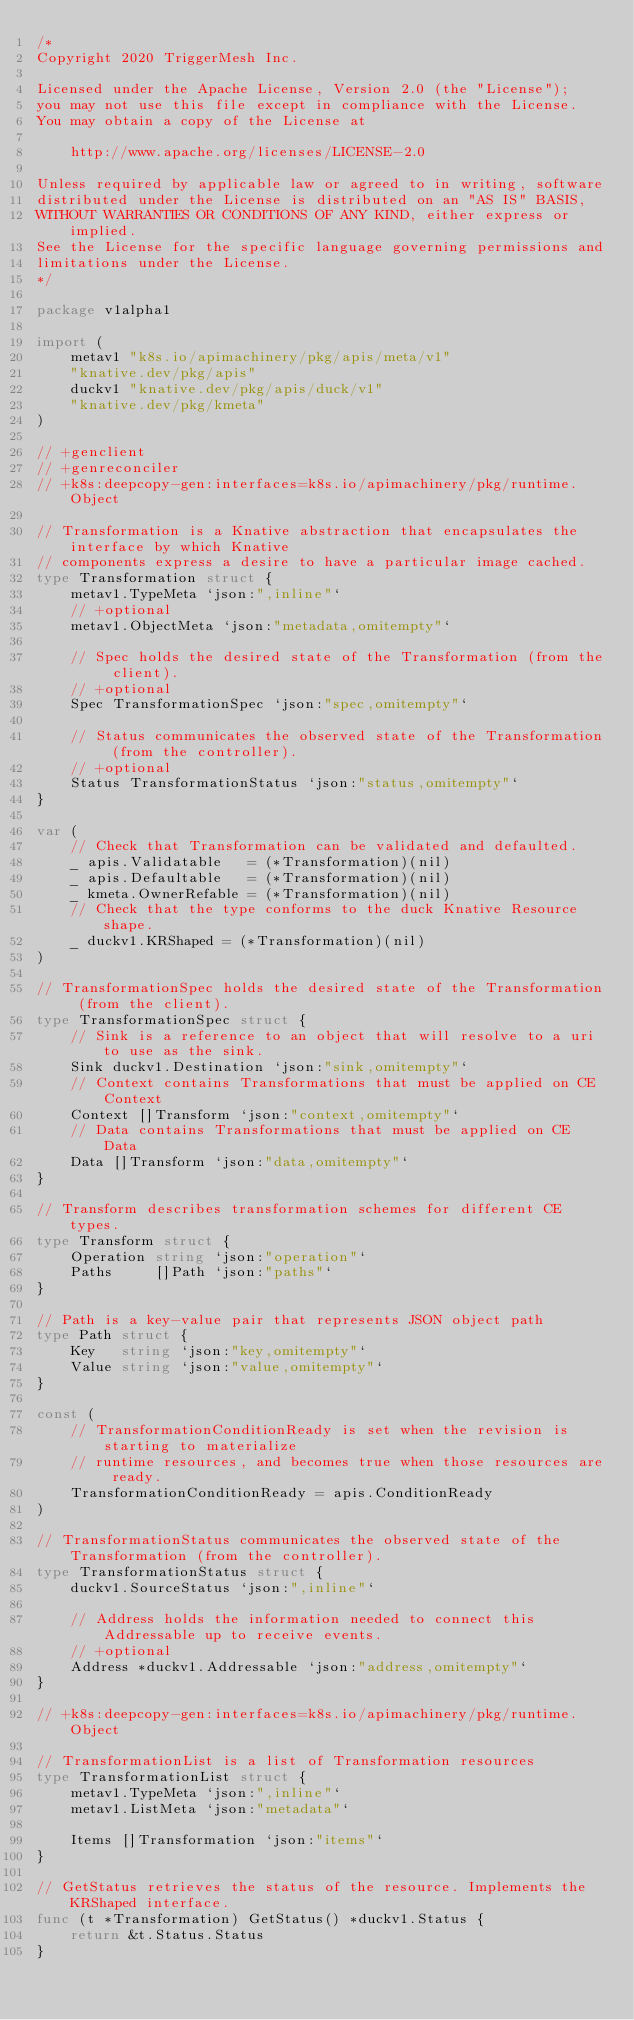<code> <loc_0><loc_0><loc_500><loc_500><_Go_>/*
Copyright 2020 TriggerMesh Inc.

Licensed under the Apache License, Version 2.0 (the "License");
you may not use this file except in compliance with the License.
You may obtain a copy of the License at

    http://www.apache.org/licenses/LICENSE-2.0

Unless required by applicable law or agreed to in writing, software
distributed under the License is distributed on an "AS IS" BASIS,
WITHOUT WARRANTIES OR CONDITIONS OF ANY KIND, either express or implied.
See the License for the specific language governing permissions and
limitations under the License.
*/

package v1alpha1

import (
	metav1 "k8s.io/apimachinery/pkg/apis/meta/v1"
	"knative.dev/pkg/apis"
	duckv1 "knative.dev/pkg/apis/duck/v1"
	"knative.dev/pkg/kmeta"
)

// +genclient
// +genreconciler
// +k8s:deepcopy-gen:interfaces=k8s.io/apimachinery/pkg/runtime.Object

// Transformation is a Knative abstraction that encapsulates the interface by which Knative
// components express a desire to have a particular image cached.
type Transformation struct {
	metav1.TypeMeta `json:",inline"`
	// +optional
	metav1.ObjectMeta `json:"metadata,omitempty"`

	// Spec holds the desired state of the Transformation (from the client).
	// +optional
	Spec TransformationSpec `json:"spec,omitempty"`

	// Status communicates the observed state of the Transformation (from the controller).
	// +optional
	Status TransformationStatus `json:"status,omitempty"`
}

var (
	// Check that Transformation can be validated and defaulted.
	_ apis.Validatable   = (*Transformation)(nil)
	_ apis.Defaultable   = (*Transformation)(nil)
	_ kmeta.OwnerRefable = (*Transformation)(nil)
	// Check that the type conforms to the duck Knative Resource shape.
	_ duckv1.KRShaped = (*Transformation)(nil)
)

// TransformationSpec holds the desired state of the Transformation (from the client).
type TransformationSpec struct {
	// Sink is a reference to an object that will resolve to a uri to use as the sink.
	Sink duckv1.Destination `json:"sink,omitempty"`
	// Context contains Transformations that must be applied on CE Context
	Context []Transform `json:"context,omitempty"`
	// Data contains Transformations that must be applied on CE Data
	Data []Transform `json:"data,omitempty"`
}

// Transform describes transformation schemes for different CE types.
type Transform struct {
	Operation string `json:"operation"`
	Paths     []Path `json:"paths"`
}

// Path is a key-value pair that represents JSON object path
type Path struct {
	Key   string `json:"key,omitempty"`
	Value string `json:"value,omitempty"`
}

const (
	// TransformationConditionReady is set when the revision is starting to materialize
	// runtime resources, and becomes true when those resources are ready.
	TransformationConditionReady = apis.ConditionReady
)

// TransformationStatus communicates the observed state of the Transformation (from the controller).
type TransformationStatus struct {
	duckv1.SourceStatus `json:",inline"`

	// Address holds the information needed to connect this Addressable up to receive events.
	// +optional
	Address *duckv1.Addressable `json:"address,omitempty"`
}

// +k8s:deepcopy-gen:interfaces=k8s.io/apimachinery/pkg/runtime.Object

// TransformationList is a list of Transformation resources
type TransformationList struct {
	metav1.TypeMeta `json:",inline"`
	metav1.ListMeta `json:"metadata"`

	Items []Transformation `json:"items"`
}

// GetStatus retrieves the status of the resource. Implements the KRShaped interface.
func (t *Transformation) GetStatus() *duckv1.Status {
	return &t.Status.Status
}
</code> 